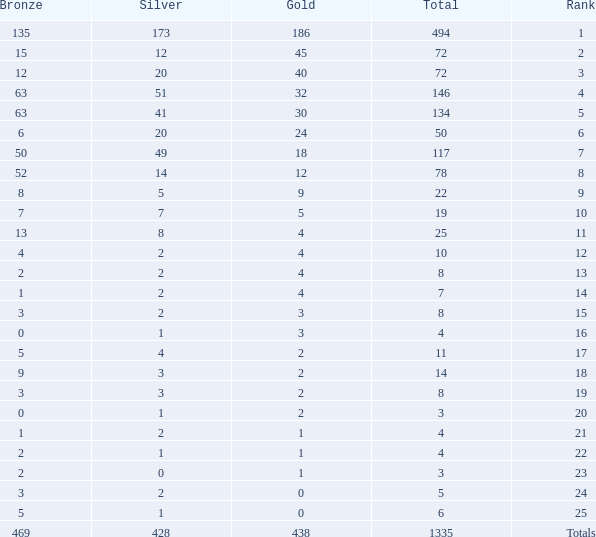What is the number of bronze medals when the total medals were 78 and there were less than 12 golds? None. 